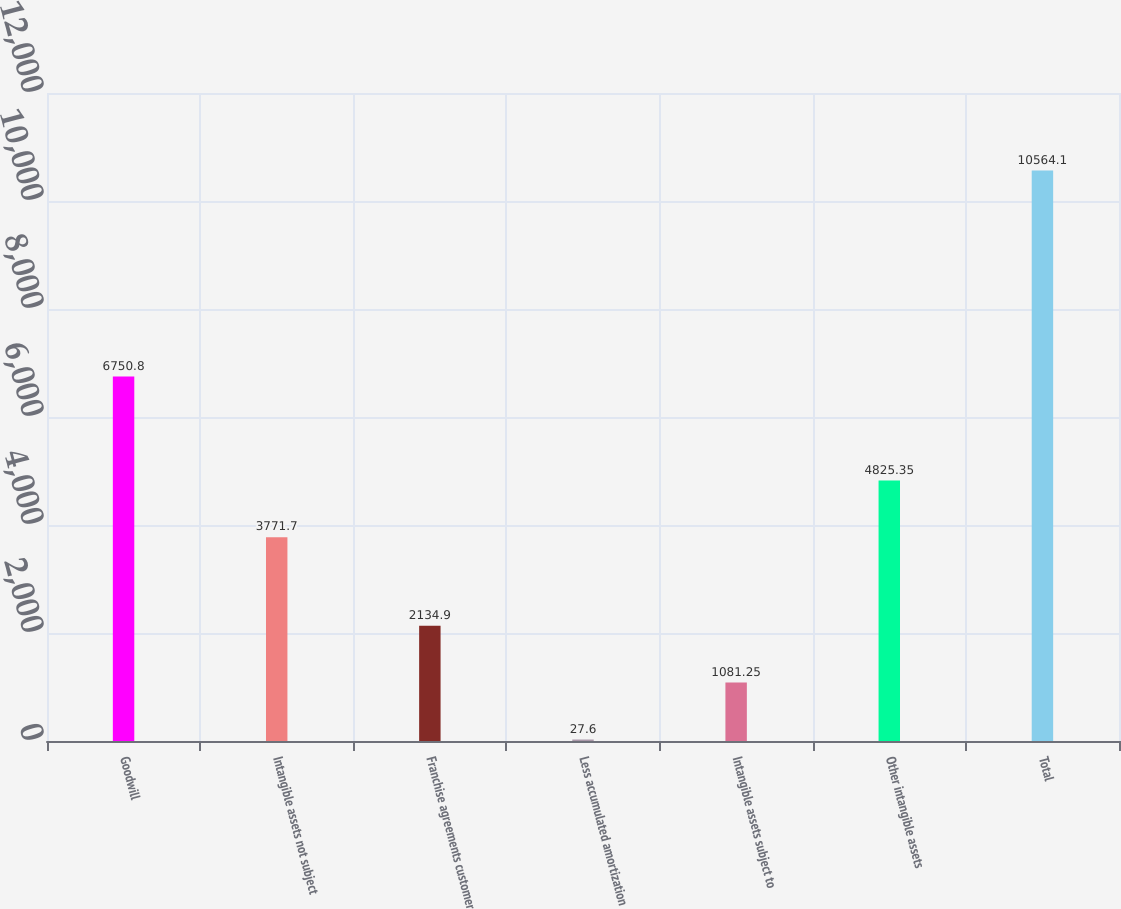Convert chart. <chart><loc_0><loc_0><loc_500><loc_500><bar_chart><fcel>Goodwill<fcel>Intangible assets not subject<fcel>Franchise agreements customer<fcel>Less accumulated amortization<fcel>Intangible assets subject to<fcel>Other intangible assets<fcel>Total<nl><fcel>6750.8<fcel>3771.7<fcel>2134.9<fcel>27.6<fcel>1081.25<fcel>4825.35<fcel>10564.1<nl></chart> 